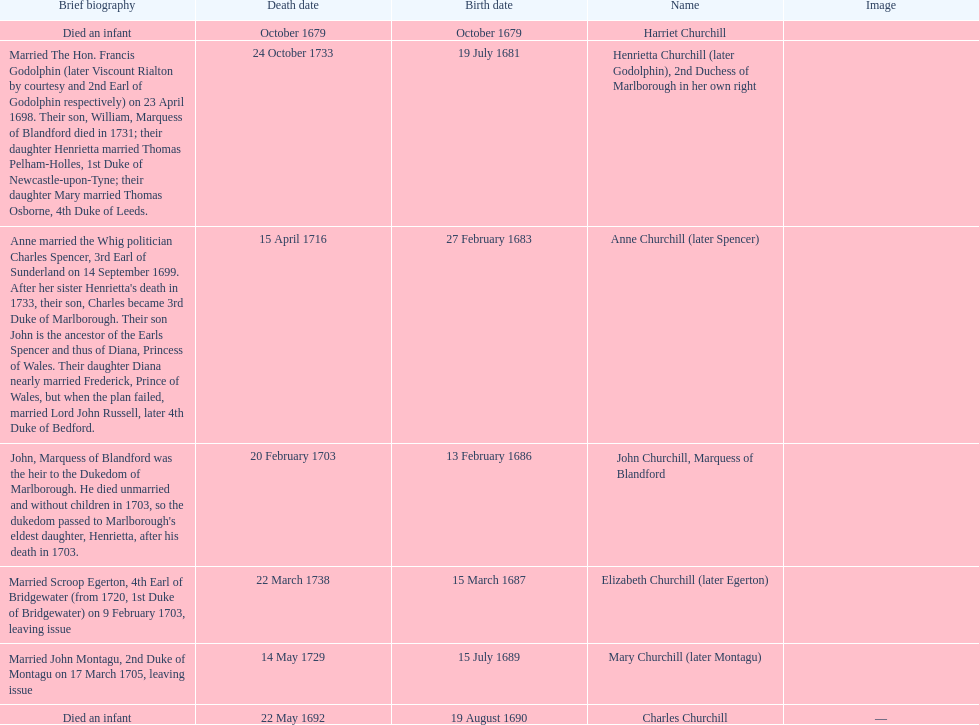Who was born before henrietta churchhill? Harriet Churchill. Can you give me this table as a dict? {'header': ['Brief biography', 'Death date', 'Birth date', 'Name', 'Image'], 'rows': [['Died an infant', 'October 1679', 'October 1679', 'Harriet Churchill', ''], ['Married The Hon. Francis Godolphin (later Viscount Rialton by courtesy and 2nd Earl of Godolphin respectively) on 23 April 1698. Their son, William, Marquess of Blandford died in 1731; their daughter Henrietta married Thomas Pelham-Holles, 1st Duke of Newcastle-upon-Tyne; their daughter Mary married Thomas Osborne, 4th Duke of Leeds.', '24 October 1733', '19 July 1681', 'Henrietta Churchill (later Godolphin), 2nd Duchess of Marlborough in her own right', ''], ["Anne married the Whig politician Charles Spencer, 3rd Earl of Sunderland on 14 September 1699. After her sister Henrietta's death in 1733, their son, Charles became 3rd Duke of Marlborough. Their son John is the ancestor of the Earls Spencer and thus of Diana, Princess of Wales. Their daughter Diana nearly married Frederick, Prince of Wales, but when the plan failed, married Lord John Russell, later 4th Duke of Bedford.", '15 April 1716', '27 February 1683', 'Anne Churchill (later Spencer)', ''], ["John, Marquess of Blandford was the heir to the Dukedom of Marlborough. He died unmarried and without children in 1703, so the dukedom passed to Marlborough's eldest daughter, Henrietta, after his death in 1703.", '20 February 1703', '13 February 1686', 'John Churchill, Marquess of Blandford', ''], ['Married Scroop Egerton, 4th Earl of Bridgewater (from 1720, 1st Duke of Bridgewater) on 9 February 1703, leaving issue', '22 March 1738', '15 March 1687', 'Elizabeth Churchill (later Egerton)', ''], ['Married John Montagu, 2nd Duke of Montagu on 17 March 1705, leaving issue', '14 May 1729', '15 July 1689', 'Mary Churchill (later Montagu)', ''], ['Died an infant', '22 May 1692', '19 August 1690', 'Charles Churchill', '—']]} 